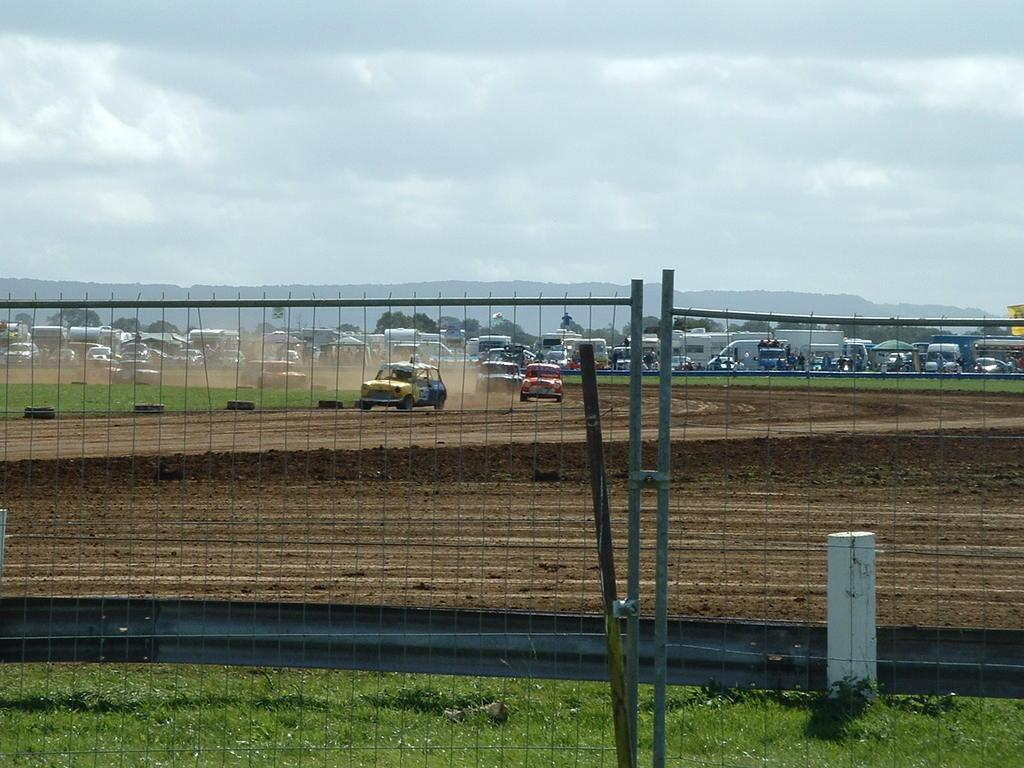What types of objects are present in the image? There are vehicles in the image. What type of vegetation is visible at the bottom of the image? There is grass at the bottom of the image. What is located in the foreground of the image? There is a fence in the foreground of the image. What can be seen in the background of the image? There are trees, hills, and the sky visible in the background of the image. How many wrens are perched on the vehicles in the image? There are no wrens present in the image. What is the profit margin of the vehicles in the image? The image does not provide information about the profit margin of the vehicles. 